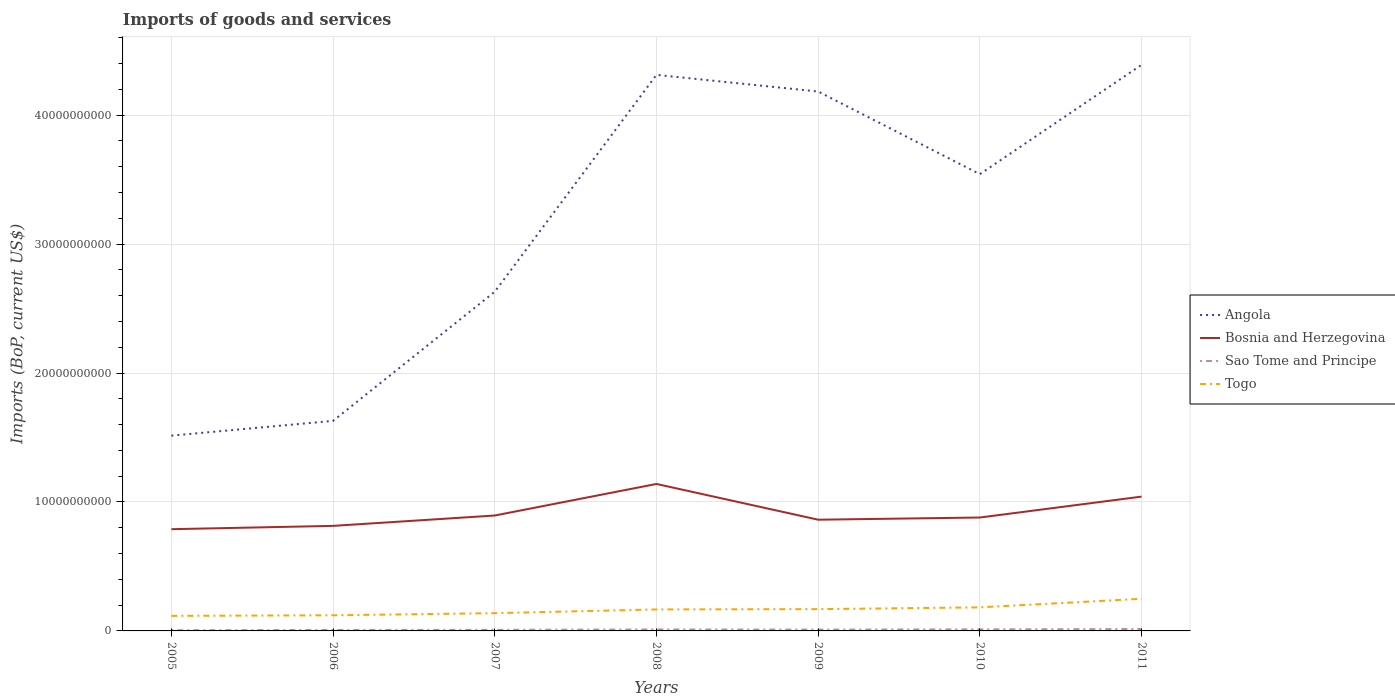How many different coloured lines are there?
Make the answer very short. 4. Across all years, what is the maximum amount spent on imports in Angola?
Offer a terse response. 1.51e+1. What is the total amount spent on imports in Angola in the graph?
Your response must be concise. -1.76e+1. What is the difference between the highest and the second highest amount spent on imports in Sao Tome and Principe?
Your answer should be very brief. 9.44e+07. Is the amount spent on imports in Sao Tome and Principe strictly greater than the amount spent on imports in Bosnia and Herzegovina over the years?
Your response must be concise. Yes. How many lines are there?
Give a very brief answer. 4. Are the values on the major ticks of Y-axis written in scientific E-notation?
Ensure brevity in your answer.  No. Does the graph contain any zero values?
Make the answer very short. No. What is the title of the graph?
Give a very brief answer. Imports of goods and services. What is the label or title of the Y-axis?
Your answer should be very brief. Imports (BoP, current US$). What is the Imports (BoP, current US$) of Angola in 2005?
Your answer should be very brief. 1.51e+1. What is the Imports (BoP, current US$) in Bosnia and Herzegovina in 2005?
Your answer should be very brief. 7.89e+09. What is the Imports (BoP, current US$) in Sao Tome and Principe in 2005?
Provide a short and direct response. 5.27e+07. What is the Imports (BoP, current US$) in Togo in 2005?
Offer a terse response. 1.17e+09. What is the Imports (BoP, current US$) in Angola in 2006?
Your answer should be compact. 1.63e+1. What is the Imports (BoP, current US$) of Bosnia and Herzegovina in 2006?
Make the answer very short. 8.15e+09. What is the Imports (BoP, current US$) of Sao Tome and Principe in 2006?
Keep it short and to the point. 7.70e+07. What is the Imports (BoP, current US$) in Togo in 2006?
Your response must be concise. 1.21e+09. What is the Imports (BoP, current US$) of Angola in 2007?
Ensure brevity in your answer.  2.63e+1. What is the Imports (BoP, current US$) in Bosnia and Herzegovina in 2007?
Make the answer very short. 8.95e+09. What is the Imports (BoP, current US$) of Sao Tome and Principe in 2007?
Your answer should be very brief. 8.35e+07. What is the Imports (BoP, current US$) in Togo in 2007?
Your answer should be very brief. 1.38e+09. What is the Imports (BoP, current US$) of Angola in 2008?
Provide a succinct answer. 4.31e+1. What is the Imports (BoP, current US$) of Bosnia and Herzegovina in 2008?
Make the answer very short. 1.14e+1. What is the Imports (BoP, current US$) of Sao Tome and Principe in 2008?
Your answer should be very brief. 1.14e+08. What is the Imports (BoP, current US$) in Togo in 2008?
Ensure brevity in your answer.  1.67e+09. What is the Imports (BoP, current US$) in Angola in 2009?
Offer a very short reply. 4.18e+1. What is the Imports (BoP, current US$) in Bosnia and Herzegovina in 2009?
Offer a very short reply. 8.62e+09. What is the Imports (BoP, current US$) in Sao Tome and Principe in 2009?
Your answer should be compact. 1.03e+08. What is the Imports (BoP, current US$) in Togo in 2009?
Keep it short and to the point. 1.69e+09. What is the Imports (BoP, current US$) in Angola in 2010?
Provide a short and direct response. 3.54e+1. What is the Imports (BoP, current US$) of Bosnia and Herzegovina in 2010?
Your response must be concise. 8.79e+09. What is the Imports (BoP, current US$) of Sao Tome and Principe in 2010?
Provide a short and direct response. 1.21e+08. What is the Imports (BoP, current US$) in Togo in 2010?
Offer a very short reply. 1.83e+09. What is the Imports (BoP, current US$) of Angola in 2011?
Make the answer very short. 4.39e+1. What is the Imports (BoP, current US$) of Bosnia and Herzegovina in 2011?
Provide a short and direct response. 1.04e+1. What is the Imports (BoP, current US$) in Sao Tome and Principe in 2011?
Provide a succinct answer. 1.47e+08. What is the Imports (BoP, current US$) in Togo in 2011?
Your answer should be compact. 2.49e+09. Across all years, what is the maximum Imports (BoP, current US$) of Angola?
Ensure brevity in your answer.  4.39e+1. Across all years, what is the maximum Imports (BoP, current US$) of Bosnia and Herzegovina?
Ensure brevity in your answer.  1.14e+1. Across all years, what is the maximum Imports (BoP, current US$) of Sao Tome and Principe?
Offer a very short reply. 1.47e+08. Across all years, what is the maximum Imports (BoP, current US$) in Togo?
Your answer should be very brief. 2.49e+09. Across all years, what is the minimum Imports (BoP, current US$) of Angola?
Offer a terse response. 1.51e+1. Across all years, what is the minimum Imports (BoP, current US$) of Bosnia and Herzegovina?
Your response must be concise. 7.89e+09. Across all years, what is the minimum Imports (BoP, current US$) of Sao Tome and Principe?
Your response must be concise. 5.27e+07. Across all years, what is the minimum Imports (BoP, current US$) in Togo?
Offer a terse response. 1.17e+09. What is the total Imports (BoP, current US$) of Angola in the graph?
Provide a short and direct response. 2.22e+11. What is the total Imports (BoP, current US$) of Bosnia and Herzegovina in the graph?
Provide a succinct answer. 6.42e+1. What is the total Imports (BoP, current US$) of Sao Tome and Principe in the graph?
Keep it short and to the point. 6.97e+08. What is the total Imports (BoP, current US$) in Togo in the graph?
Provide a succinct answer. 1.14e+1. What is the difference between the Imports (BoP, current US$) of Angola in 2005 and that in 2006?
Make the answer very short. -1.14e+09. What is the difference between the Imports (BoP, current US$) of Bosnia and Herzegovina in 2005 and that in 2006?
Keep it short and to the point. -2.56e+08. What is the difference between the Imports (BoP, current US$) of Sao Tome and Principe in 2005 and that in 2006?
Your answer should be very brief. -2.43e+07. What is the difference between the Imports (BoP, current US$) of Togo in 2005 and that in 2006?
Your answer should be compact. -4.51e+07. What is the difference between the Imports (BoP, current US$) of Angola in 2005 and that in 2007?
Your response must be concise. -1.12e+1. What is the difference between the Imports (BoP, current US$) of Bosnia and Herzegovina in 2005 and that in 2007?
Your response must be concise. -1.06e+09. What is the difference between the Imports (BoP, current US$) of Sao Tome and Principe in 2005 and that in 2007?
Your answer should be compact. -3.09e+07. What is the difference between the Imports (BoP, current US$) in Togo in 2005 and that in 2007?
Give a very brief answer. -2.09e+08. What is the difference between the Imports (BoP, current US$) in Angola in 2005 and that in 2008?
Offer a very short reply. -2.80e+1. What is the difference between the Imports (BoP, current US$) in Bosnia and Herzegovina in 2005 and that in 2008?
Your answer should be compact. -3.51e+09. What is the difference between the Imports (BoP, current US$) in Sao Tome and Principe in 2005 and that in 2008?
Provide a short and direct response. -6.09e+07. What is the difference between the Imports (BoP, current US$) in Togo in 2005 and that in 2008?
Keep it short and to the point. -4.98e+08. What is the difference between the Imports (BoP, current US$) of Angola in 2005 and that in 2009?
Your response must be concise. -2.67e+1. What is the difference between the Imports (BoP, current US$) of Bosnia and Herzegovina in 2005 and that in 2009?
Make the answer very short. -7.35e+08. What is the difference between the Imports (BoP, current US$) of Sao Tome and Principe in 2005 and that in 2009?
Give a very brief answer. -5.01e+07. What is the difference between the Imports (BoP, current US$) in Togo in 2005 and that in 2009?
Make the answer very short. -5.22e+08. What is the difference between the Imports (BoP, current US$) of Angola in 2005 and that in 2010?
Ensure brevity in your answer.  -2.03e+1. What is the difference between the Imports (BoP, current US$) of Bosnia and Herzegovina in 2005 and that in 2010?
Keep it short and to the point. -9.04e+08. What is the difference between the Imports (BoP, current US$) of Sao Tome and Principe in 2005 and that in 2010?
Make the answer very short. -6.79e+07. What is the difference between the Imports (BoP, current US$) in Togo in 2005 and that in 2010?
Your answer should be compact. -6.60e+08. What is the difference between the Imports (BoP, current US$) of Angola in 2005 and that in 2011?
Ensure brevity in your answer.  -2.88e+1. What is the difference between the Imports (BoP, current US$) in Bosnia and Herzegovina in 2005 and that in 2011?
Ensure brevity in your answer.  -2.53e+09. What is the difference between the Imports (BoP, current US$) of Sao Tome and Principe in 2005 and that in 2011?
Your answer should be very brief. -9.44e+07. What is the difference between the Imports (BoP, current US$) of Togo in 2005 and that in 2011?
Your answer should be very brief. -1.33e+09. What is the difference between the Imports (BoP, current US$) of Angola in 2006 and that in 2007?
Your response must be concise. -1.00e+1. What is the difference between the Imports (BoP, current US$) of Bosnia and Herzegovina in 2006 and that in 2007?
Give a very brief answer. -8.03e+08. What is the difference between the Imports (BoP, current US$) in Sao Tome and Principe in 2006 and that in 2007?
Give a very brief answer. -6.53e+06. What is the difference between the Imports (BoP, current US$) in Togo in 2006 and that in 2007?
Your answer should be compact. -1.64e+08. What is the difference between the Imports (BoP, current US$) in Angola in 2006 and that in 2008?
Your answer should be very brief. -2.68e+1. What is the difference between the Imports (BoP, current US$) in Bosnia and Herzegovina in 2006 and that in 2008?
Your response must be concise. -3.25e+09. What is the difference between the Imports (BoP, current US$) of Sao Tome and Principe in 2006 and that in 2008?
Make the answer very short. -3.66e+07. What is the difference between the Imports (BoP, current US$) in Togo in 2006 and that in 2008?
Make the answer very short. -4.53e+08. What is the difference between the Imports (BoP, current US$) in Angola in 2006 and that in 2009?
Provide a short and direct response. -2.55e+1. What is the difference between the Imports (BoP, current US$) in Bosnia and Herzegovina in 2006 and that in 2009?
Provide a succinct answer. -4.79e+08. What is the difference between the Imports (BoP, current US$) in Sao Tome and Principe in 2006 and that in 2009?
Offer a terse response. -2.57e+07. What is the difference between the Imports (BoP, current US$) in Togo in 2006 and that in 2009?
Keep it short and to the point. -4.77e+08. What is the difference between the Imports (BoP, current US$) of Angola in 2006 and that in 2010?
Offer a very short reply. -1.91e+1. What is the difference between the Imports (BoP, current US$) in Bosnia and Herzegovina in 2006 and that in 2010?
Ensure brevity in your answer.  -6.48e+08. What is the difference between the Imports (BoP, current US$) of Sao Tome and Principe in 2006 and that in 2010?
Your response must be concise. -4.35e+07. What is the difference between the Imports (BoP, current US$) in Togo in 2006 and that in 2010?
Your response must be concise. -6.15e+08. What is the difference between the Imports (BoP, current US$) in Angola in 2006 and that in 2011?
Offer a very short reply. -2.76e+1. What is the difference between the Imports (BoP, current US$) of Bosnia and Herzegovina in 2006 and that in 2011?
Make the answer very short. -2.27e+09. What is the difference between the Imports (BoP, current US$) in Sao Tome and Principe in 2006 and that in 2011?
Ensure brevity in your answer.  -7.01e+07. What is the difference between the Imports (BoP, current US$) in Togo in 2006 and that in 2011?
Give a very brief answer. -1.28e+09. What is the difference between the Imports (BoP, current US$) of Angola in 2007 and that in 2008?
Your answer should be very brief. -1.68e+1. What is the difference between the Imports (BoP, current US$) in Bosnia and Herzegovina in 2007 and that in 2008?
Provide a short and direct response. -2.45e+09. What is the difference between the Imports (BoP, current US$) of Sao Tome and Principe in 2007 and that in 2008?
Ensure brevity in your answer.  -3.01e+07. What is the difference between the Imports (BoP, current US$) of Togo in 2007 and that in 2008?
Keep it short and to the point. -2.89e+08. What is the difference between the Imports (BoP, current US$) of Angola in 2007 and that in 2009?
Ensure brevity in your answer.  -1.55e+1. What is the difference between the Imports (BoP, current US$) in Bosnia and Herzegovina in 2007 and that in 2009?
Keep it short and to the point. 3.25e+08. What is the difference between the Imports (BoP, current US$) of Sao Tome and Principe in 2007 and that in 2009?
Offer a very short reply. -1.92e+07. What is the difference between the Imports (BoP, current US$) of Togo in 2007 and that in 2009?
Offer a very short reply. -3.12e+08. What is the difference between the Imports (BoP, current US$) in Angola in 2007 and that in 2010?
Your answer should be very brief. -9.12e+09. What is the difference between the Imports (BoP, current US$) in Bosnia and Herzegovina in 2007 and that in 2010?
Provide a succinct answer. 1.56e+08. What is the difference between the Imports (BoP, current US$) in Sao Tome and Principe in 2007 and that in 2010?
Your answer should be compact. -3.70e+07. What is the difference between the Imports (BoP, current US$) in Togo in 2007 and that in 2010?
Make the answer very short. -4.51e+08. What is the difference between the Imports (BoP, current US$) of Angola in 2007 and that in 2011?
Keep it short and to the point. -1.76e+1. What is the difference between the Imports (BoP, current US$) in Bosnia and Herzegovina in 2007 and that in 2011?
Give a very brief answer. -1.47e+09. What is the difference between the Imports (BoP, current US$) in Sao Tome and Principe in 2007 and that in 2011?
Give a very brief answer. -6.35e+07. What is the difference between the Imports (BoP, current US$) of Togo in 2007 and that in 2011?
Your response must be concise. -1.12e+09. What is the difference between the Imports (BoP, current US$) of Angola in 2008 and that in 2009?
Offer a very short reply. 1.29e+09. What is the difference between the Imports (BoP, current US$) of Bosnia and Herzegovina in 2008 and that in 2009?
Provide a succinct answer. 2.77e+09. What is the difference between the Imports (BoP, current US$) in Sao Tome and Principe in 2008 and that in 2009?
Ensure brevity in your answer.  1.08e+07. What is the difference between the Imports (BoP, current US$) in Togo in 2008 and that in 2009?
Give a very brief answer. -2.35e+07. What is the difference between the Imports (BoP, current US$) in Angola in 2008 and that in 2010?
Your response must be concise. 7.70e+09. What is the difference between the Imports (BoP, current US$) in Bosnia and Herzegovina in 2008 and that in 2010?
Your answer should be very brief. 2.60e+09. What is the difference between the Imports (BoP, current US$) of Sao Tome and Principe in 2008 and that in 2010?
Give a very brief answer. -6.93e+06. What is the difference between the Imports (BoP, current US$) of Togo in 2008 and that in 2010?
Your answer should be very brief. -1.62e+08. What is the difference between the Imports (BoP, current US$) of Angola in 2008 and that in 2011?
Your response must be concise. -7.77e+08. What is the difference between the Imports (BoP, current US$) in Bosnia and Herzegovina in 2008 and that in 2011?
Provide a short and direct response. 9.82e+08. What is the difference between the Imports (BoP, current US$) in Sao Tome and Principe in 2008 and that in 2011?
Your answer should be very brief. -3.35e+07. What is the difference between the Imports (BoP, current US$) of Togo in 2008 and that in 2011?
Provide a short and direct response. -8.27e+08. What is the difference between the Imports (BoP, current US$) in Angola in 2009 and that in 2010?
Provide a succinct answer. 6.41e+09. What is the difference between the Imports (BoP, current US$) in Bosnia and Herzegovina in 2009 and that in 2010?
Give a very brief answer. -1.69e+08. What is the difference between the Imports (BoP, current US$) in Sao Tome and Principe in 2009 and that in 2010?
Ensure brevity in your answer.  -1.78e+07. What is the difference between the Imports (BoP, current US$) in Togo in 2009 and that in 2010?
Your answer should be compact. -1.38e+08. What is the difference between the Imports (BoP, current US$) in Angola in 2009 and that in 2011?
Your answer should be very brief. -2.07e+09. What is the difference between the Imports (BoP, current US$) of Bosnia and Herzegovina in 2009 and that in 2011?
Ensure brevity in your answer.  -1.79e+09. What is the difference between the Imports (BoP, current US$) in Sao Tome and Principe in 2009 and that in 2011?
Provide a short and direct response. -4.43e+07. What is the difference between the Imports (BoP, current US$) in Togo in 2009 and that in 2011?
Your response must be concise. -8.03e+08. What is the difference between the Imports (BoP, current US$) in Angola in 2010 and that in 2011?
Provide a short and direct response. -8.48e+09. What is the difference between the Imports (BoP, current US$) of Bosnia and Herzegovina in 2010 and that in 2011?
Keep it short and to the point. -1.62e+09. What is the difference between the Imports (BoP, current US$) in Sao Tome and Principe in 2010 and that in 2011?
Offer a very short reply. -2.66e+07. What is the difference between the Imports (BoP, current US$) of Togo in 2010 and that in 2011?
Your answer should be very brief. -6.65e+08. What is the difference between the Imports (BoP, current US$) in Angola in 2005 and the Imports (BoP, current US$) in Bosnia and Herzegovina in 2006?
Offer a terse response. 7.00e+09. What is the difference between the Imports (BoP, current US$) in Angola in 2005 and the Imports (BoP, current US$) in Sao Tome and Principe in 2006?
Your response must be concise. 1.51e+1. What is the difference between the Imports (BoP, current US$) in Angola in 2005 and the Imports (BoP, current US$) in Togo in 2006?
Offer a very short reply. 1.39e+1. What is the difference between the Imports (BoP, current US$) of Bosnia and Herzegovina in 2005 and the Imports (BoP, current US$) of Sao Tome and Principe in 2006?
Your response must be concise. 7.81e+09. What is the difference between the Imports (BoP, current US$) of Bosnia and Herzegovina in 2005 and the Imports (BoP, current US$) of Togo in 2006?
Your answer should be compact. 6.68e+09. What is the difference between the Imports (BoP, current US$) of Sao Tome and Principe in 2005 and the Imports (BoP, current US$) of Togo in 2006?
Provide a short and direct response. -1.16e+09. What is the difference between the Imports (BoP, current US$) in Angola in 2005 and the Imports (BoP, current US$) in Bosnia and Herzegovina in 2007?
Give a very brief answer. 6.19e+09. What is the difference between the Imports (BoP, current US$) in Angola in 2005 and the Imports (BoP, current US$) in Sao Tome and Principe in 2007?
Your response must be concise. 1.51e+1. What is the difference between the Imports (BoP, current US$) in Angola in 2005 and the Imports (BoP, current US$) in Togo in 2007?
Offer a terse response. 1.38e+1. What is the difference between the Imports (BoP, current US$) of Bosnia and Herzegovina in 2005 and the Imports (BoP, current US$) of Sao Tome and Principe in 2007?
Provide a succinct answer. 7.81e+09. What is the difference between the Imports (BoP, current US$) of Bosnia and Herzegovina in 2005 and the Imports (BoP, current US$) of Togo in 2007?
Give a very brief answer. 6.51e+09. What is the difference between the Imports (BoP, current US$) of Sao Tome and Principe in 2005 and the Imports (BoP, current US$) of Togo in 2007?
Give a very brief answer. -1.32e+09. What is the difference between the Imports (BoP, current US$) in Angola in 2005 and the Imports (BoP, current US$) in Bosnia and Herzegovina in 2008?
Ensure brevity in your answer.  3.75e+09. What is the difference between the Imports (BoP, current US$) in Angola in 2005 and the Imports (BoP, current US$) in Sao Tome and Principe in 2008?
Make the answer very short. 1.50e+1. What is the difference between the Imports (BoP, current US$) of Angola in 2005 and the Imports (BoP, current US$) of Togo in 2008?
Offer a terse response. 1.35e+1. What is the difference between the Imports (BoP, current US$) of Bosnia and Herzegovina in 2005 and the Imports (BoP, current US$) of Sao Tome and Principe in 2008?
Your answer should be very brief. 7.78e+09. What is the difference between the Imports (BoP, current US$) of Bosnia and Herzegovina in 2005 and the Imports (BoP, current US$) of Togo in 2008?
Make the answer very short. 6.22e+09. What is the difference between the Imports (BoP, current US$) of Sao Tome and Principe in 2005 and the Imports (BoP, current US$) of Togo in 2008?
Provide a short and direct response. -1.61e+09. What is the difference between the Imports (BoP, current US$) of Angola in 2005 and the Imports (BoP, current US$) of Bosnia and Herzegovina in 2009?
Give a very brief answer. 6.52e+09. What is the difference between the Imports (BoP, current US$) of Angola in 2005 and the Imports (BoP, current US$) of Sao Tome and Principe in 2009?
Provide a succinct answer. 1.50e+1. What is the difference between the Imports (BoP, current US$) in Angola in 2005 and the Imports (BoP, current US$) in Togo in 2009?
Give a very brief answer. 1.35e+1. What is the difference between the Imports (BoP, current US$) in Bosnia and Herzegovina in 2005 and the Imports (BoP, current US$) in Sao Tome and Principe in 2009?
Your answer should be very brief. 7.79e+09. What is the difference between the Imports (BoP, current US$) in Bosnia and Herzegovina in 2005 and the Imports (BoP, current US$) in Togo in 2009?
Ensure brevity in your answer.  6.20e+09. What is the difference between the Imports (BoP, current US$) of Sao Tome and Principe in 2005 and the Imports (BoP, current US$) of Togo in 2009?
Give a very brief answer. -1.64e+09. What is the difference between the Imports (BoP, current US$) of Angola in 2005 and the Imports (BoP, current US$) of Bosnia and Herzegovina in 2010?
Keep it short and to the point. 6.35e+09. What is the difference between the Imports (BoP, current US$) in Angola in 2005 and the Imports (BoP, current US$) in Sao Tome and Principe in 2010?
Offer a very short reply. 1.50e+1. What is the difference between the Imports (BoP, current US$) of Angola in 2005 and the Imports (BoP, current US$) of Togo in 2010?
Your answer should be compact. 1.33e+1. What is the difference between the Imports (BoP, current US$) of Bosnia and Herzegovina in 2005 and the Imports (BoP, current US$) of Sao Tome and Principe in 2010?
Your answer should be very brief. 7.77e+09. What is the difference between the Imports (BoP, current US$) of Bosnia and Herzegovina in 2005 and the Imports (BoP, current US$) of Togo in 2010?
Your response must be concise. 6.06e+09. What is the difference between the Imports (BoP, current US$) in Sao Tome and Principe in 2005 and the Imports (BoP, current US$) in Togo in 2010?
Provide a short and direct response. -1.78e+09. What is the difference between the Imports (BoP, current US$) in Angola in 2005 and the Imports (BoP, current US$) in Bosnia and Herzegovina in 2011?
Your response must be concise. 4.73e+09. What is the difference between the Imports (BoP, current US$) of Angola in 2005 and the Imports (BoP, current US$) of Sao Tome and Principe in 2011?
Offer a very short reply. 1.50e+1. What is the difference between the Imports (BoP, current US$) of Angola in 2005 and the Imports (BoP, current US$) of Togo in 2011?
Make the answer very short. 1.27e+1. What is the difference between the Imports (BoP, current US$) in Bosnia and Herzegovina in 2005 and the Imports (BoP, current US$) in Sao Tome and Principe in 2011?
Offer a terse response. 7.74e+09. What is the difference between the Imports (BoP, current US$) in Bosnia and Herzegovina in 2005 and the Imports (BoP, current US$) in Togo in 2011?
Make the answer very short. 5.40e+09. What is the difference between the Imports (BoP, current US$) in Sao Tome and Principe in 2005 and the Imports (BoP, current US$) in Togo in 2011?
Provide a succinct answer. -2.44e+09. What is the difference between the Imports (BoP, current US$) of Angola in 2006 and the Imports (BoP, current US$) of Bosnia and Herzegovina in 2007?
Give a very brief answer. 7.34e+09. What is the difference between the Imports (BoP, current US$) in Angola in 2006 and the Imports (BoP, current US$) in Sao Tome and Principe in 2007?
Your response must be concise. 1.62e+1. What is the difference between the Imports (BoP, current US$) of Angola in 2006 and the Imports (BoP, current US$) of Togo in 2007?
Make the answer very short. 1.49e+1. What is the difference between the Imports (BoP, current US$) of Bosnia and Herzegovina in 2006 and the Imports (BoP, current US$) of Sao Tome and Principe in 2007?
Your answer should be compact. 8.06e+09. What is the difference between the Imports (BoP, current US$) of Bosnia and Herzegovina in 2006 and the Imports (BoP, current US$) of Togo in 2007?
Your response must be concise. 6.77e+09. What is the difference between the Imports (BoP, current US$) in Sao Tome and Principe in 2006 and the Imports (BoP, current US$) in Togo in 2007?
Your answer should be very brief. -1.30e+09. What is the difference between the Imports (BoP, current US$) of Angola in 2006 and the Imports (BoP, current US$) of Bosnia and Herzegovina in 2008?
Your answer should be very brief. 4.89e+09. What is the difference between the Imports (BoP, current US$) in Angola in 2006 and the Imports (BoP, current US$) in Sao Tome and Principe in 2008?
Provide a succinct answer. 1.62e+1. What is the difference between the Imports (BoP, current US$) in Angola in 2006 and the Imports (BoP, current US$) in Togo in 2008?
Offer a very short reply. 1.46e+1. What is the difference between the Imports (BoP, current US$) in Bosnia and Herzegovina in 2006 and the Imports (BoP, current US$) in Sao Tome and Principe in 2008?
Offer a terse response. 8.03e+09. What is the difference between the Imports (BoP, current US$) in Bosnia and Herzegovina in 2006 and the Imports (BoP, current US$) in Togo in 2008?
Offer a very short reply. 6.48e+09. What is the difference between the Imports (BoP, current US$) in Sao Tome and Principe in 2006 and the Imports (BoP, current US$) in Togo in 2008?
Ensure brevity in your answer.  -1.59e+09. What is the difference between the Imports (BoP, current US$) of Angola in 2006 and the Imports (BoP, current US$) of Bosnia and Herzegovina in 2009?
Your response must be concise. 7.66e+09. What is the difference between the Imports (BoP, current US$) of Angola in 2006 and the Imports (BoP, current US$) of Sao Tome and Principe in 2009?
Provide a succinct answer. 1.62e+1. What is the difference between the Imports (BoP, current US$) of Angola in 2006 and the Imports (BoP, current US$) of Togo in 2009?
Provide a short and direct response. 1.46e+1. What is the difference between the Imports (BoP, current US$) of Bosnia and Herzegovina in 2006 and the Imports (BoP, current US$) of Sao Tome and Principe in 2009?
Keep it short and to the point. 8.04e+09. What is the difference between the Imports (BoP, current US$) in Bosnia and Herzegovina in 2006 and the Imports (BoP, current US$) in Togo in 2009?
Offer a very short reply. 6.46e+09. What is the difference between the Imports (BoP, current US$) in Sao Tome and Principe in 2006 and the Imports (BoP, current US$) in Togo in 2009?
Provide a succinct answer. -1.61e+09. What is the difference between the Imports (BoP, current US$) in Angola in 2006 and the Imports (BoP, current US$) in Bosnia and Herzegovina in 2010?
Offer a terse response. 7.49e+09. What is the difference between the Imports (BoP, current US$) in Angola in 2006 and the Imports (BoP, current US$) in Sao Tome and Principe in 2010?
Your answer should be very brief. 1.62e+1. What is the difference between the Imports (BoP, current US$) of Angola in 2006 and the Imports (BoP, current US$) of Togo in 2010?
Keep it short and to the point. 1.45e+1. What is the difference between the Imports (BoP, current US$) of Bosnia and Herzegovina in 2006 and the Imports (BoP, current US$) of Sao Tome and Principe in 2010?
Provide a succinct answer. 8.03e+09. What is the difference between the Imports (BoP, current US$) in Bosnia and Herzegovina in 2006 and the Imports (BoP, current US$) in Togo in 2010?
Offer a very short reply. 6.32e+09. What is the difference between the Imports (BoP, current US$) of Sao Tome and Principe in 2006 and the Imports (BoP, current US$) of Togo in 2010?
Ensure brevity in your answer.  -1.75e+09. What is the difference between the Imports (BoP, current US$) of Angola in 2006 and the Imports (BoP, current US$) of Bosnia and Herzegovina in 2011?
Offer a terse response. 5.87e+09. What is the difference between the Imports (BoP, current US$) in Angola in 2006 and the Imports (BoP, current US$) in Sao Tome and Principe in 2011?
Your answer should be compact. 1.61e+1. What is the difference between the Imports (BoP, current US$) of Angola in 2006 and the Imports (BoP, current US$) of Togo in 2011?
Your answer should be very brief. 1.38e+1. What is the difference between the Imports (BoP, current US$) of Bosnia and Herzegovina in 2006 and the Imports (BoP, current US$) of Sao Tome and Principe in 2011?
Offer a terse response. 8.00e+09. What is the difference between the Imports (BoP, current US$) of Bosnia and Herzegovina in 2006 and the Imports (BoP, current US$) of Togo in 2011?
Keep it short and to the point. 5.65e+09. What is the difference between the Imports (BoP, current US$) in Sao Tome and Principe in 2006 and the Imports (BoP, current US$) in Togo in 2011?
Your answer should be very brief. -2.42e+09. What is the difference between the Imports (BoP, current US$) of Angola in 2007 and the Imports (BoP, current US$) of Bosnia and Herzegovina in 2008?
Ensure brevity in your answer.  1.49e+1. What is the difference between the Imports (BoP, current US$) in Angola in 2007 and the Imports (BoP, current US$) in Sao Tome and Principe in 2008?
Your answer should be very brief. 2.62e+1. What is the difference between the Imports (BoP, current US$) in Angola in 2007 and the Imports (BoP, current US$) in Togo in 2008?
Offer a terse response. 2.46e+1. What is the difference between the Imports (BoP, current US$) of Bosnia and Herzegovina in 2007 and the Imports (BoP, current US$) of Sao Tome and Principe in 2008?
Ensure brevity in your answer.  8.84e+09. What is the difference between the Imports (BoP, current US$) in Bosnia and Herzegovina in 2007 and the Imports (BoP, current US$) in Togo in 2008?
Provide a succinct answer. 7.28e+09. What is the difference between the Imports (BoP, current US$) of Sao Tome and Principe in 2007 and the Imports (BoP, current US$) of Togo in 2008?
Offer a terse response. -1.58e+09. What is the difference between the Imports (BoP, current US$) of Angola in 2007 and the Imports (BoP, current US$) of Bosnia and Herzegovina in 2009?
Make the answer very short. 1.77e+1. What is the difference between the Imports (BoP, current US$) in Angola in 2007 and the Imports (BoP, current US$) in Sao Tome and Principe in 2009?
Offer a very short reply. 2.62e+1. What is the difference between the Imports (BoP, current US$) in Angola in 2007 and the Imports (BoP, current US$) in Togo in 2009?
Give a very brief answer. 2.46e+1. What is the difference between the Imports (BoP, current US$) in Bosnia and Herzegovina in 2007 and the Imports (BoP, current US$) in Sao Tome and Principe in 2009?
Offer a very short reply. 8.85e+09. What is the difference between the Imports (BoP, current US$) of Bosnia and Herzegovina in 2007 and the Imports (BoP, current US$) of Togo in 2009?
Give a very brief answer. 7.26e+09. What is the difference between the Imports (BoP, current US$) in Sao Tome and Principe in 2007 and the Imports (BoP, current US$) in Togo in 2009?
Offer a very short reply. -1.61e+09. What is the difference between the Imports (BoP, current US$) of Angola in 2007 and the Imports (BoP, current US$) of Bosnia and Herzegovina in 2010?
Provide a succinct answer. 1.75e+1. What is the difference between the Imports (BoP, current US$) in Angola in 2007 and the Imports (BoP, current US$) in Sao Tome and Principe in 2010?
Offer a terse response. 2.62e+1. What is the difference between the Imports (BoP, current US$) of Angola in 2007 and the Imports (BoP, current US$) of Togo in 2010?
Offer a very short reply. 2.45e+1. What is the difference between the Imports (BoP, current US$) in Bosnia and Herzegovina in 2007 and the Imports (BoP, current US$) in Sao Tome and Principe in 2010?
Give a very brief answer. 8.83e+09. What is the difference between the Imports (BoP, current US$) of Bosnia and Herzegovina in 2007 and the Imports (BoP, current US$) of Togo in 2010?
Your answer should be compact. 7.12e+09. What is the difference between the Imports (BoP, current US$) of Sao Tome and Principe in 2007 and the Imports (BoP, current US$) of Togo in 2010?
Make the answer very short. -1.74e+09. What is the difference between the Imports (BoP, current US$) in Angola in 2007 and the Imports (BoP, current US$) in Bosnia and Herzegovina in 2011?
Provide a succinct answer. 1.59e+1. What is the difference between the Imports (BoP, current US$) of Angola in 2007 and the Imports (BoP, current US$) of Sao Tome and Principe in 2011?
Offer a terse response. 2.62e+1. What is the difference between the Imports (BoP, current US$) in Angola in 2007 and the Imports (BoP, current US$) in Togo in 2011?
Your answer should be very brief. 2.38e+1. What is the difference between the Imports (BoP, current US$) of Bosnia and Herzegovina in 2007 and the Imports (BoP, current US$) of Sao Tome and Principe in 2011?
Give a very brief answer. 8.80e+09. What is the difference between the Imports (BoP, current US$) in Bosnia and Herzegovina in 2007 and the Imports (BoP, current US$) in Togo in 2011?
Ensure brevity in your answer.  6.46e+09. What is the difference between the Imports (BoP, current US$) in Sao Tome and Principe in 2007 and the Imports (BoP, current US$) in Togo in 2011?
Your response must be concise. -2.41e+09. What is the difference between the Imports (BoP, current US$) of Angola in 2008 and the Imports (BoP, current US$) of Bosnia and Herzegovina in 2009?
Offer a very short reply. 3.45e+1. What is the difference between the Imports (BoP, current US$) in Angola in 2008 and the Imports (BoP, current US$) in Sao Tome and Principe in 2009?
Provide a succinct answer. 4.30e+1. What is the difference between the Imports (BoP, current US$) of Angola in 2008 and the Imports (BoP, current US$) of Togo in 2009?
Your answer should be very brief. 4.14e+1. What is the difference between the Imports (BoP, current US$) of Bosnia and Herzegovina in 2008 and the Imports (BoP, current US$) of Sao Tome and Principe in 2009?
Make the answer very short. 1.13e+1. What is the difference between the Imports (BoP, current US$) in Bosnia and Herzegovina in 2008 and the Imports (BoP, current US$) in Togo in 2009?
Make the answer very short. 9.71e+09. What is the difference between the Imports (BoP, current US$) of Sao Tome and Principe in 2008 and the Imports (BoP, current US$) of Togo in 2009?
Provide a short and direct response. -1.58e+09. What is the difference between the Imports (BoP, current US$) of Angola in 2008 and the Imports (BoP, current US$) of Bosnia and Herzegovina in 2010?
Offer a terse response. 3.43e+1. What is the difference between the Imports (BoP, current US$) in Angola in 2008 and the Imports (BoP, current US$) in Sao Tome and Principe in 2010?
Provide a short and direct response. 4.30e+1. What is the difference between the Imports (BoP, current US$) in Angola in 2008 and the Imports (BoP, current US$) in Togo in 2010?
Make the answer very short. 4.13e+1. What is the difference between the Imports (BoP, current US$) of Bosnia and Herzegovina in 2008 and the Imports (BoP, current US$) of Sao Tome and Principe in 2010?
Your answer should be compact. 1.13e+1. What is the difference between the Imports (BoP, current US$) in Bosnia and Herzegovina in 2008 and the Imports (BoP, current US$) in Togo in 2010?
Provide a succinct answer. 9.57e+09. What is the difference between the Imports (BoP, current US$) in Sao Tome and Principe in 2008 and the Imports (BoP, current US$) in Togo in 2010?
Your answer should be compact. -1.71e+09. What is the difference between the Imports (BoP, current US$) in Angola in 2008 and the Imports (BoP, current US$) in Bosnia and Herzegovina in 2011?
Your answer should be compact. 3.27e+1. What is the difference between the Imports (BoP, current US$) of Angola in 2008 and the Imports (BoP, current US$) of Sao Tome and Principe in 2011?
Your answer should be compact. 4.30e+1. What is the difference between the Imports (BoP, current US$) of Angola in 2008 and the Imports (BoP, current US$) of Togo in 2011?
Give a very brief answer. 4.06e+1. What is the difference between the Imports (BoP, current US$) of Bosnia and Herzegovina in 2008 and the Imports (BoP, current US$) of Sao Tome and Principe in 2011?
Keep it short and to the point. 1.13e+1. What is the difference between the Imports (BoP, current US$) of Bosnia and Herzegovina in 2008 and the Imports (BoP, current US$) of Togo in 2011?
Give a very brief answer. 8.90e+09. What is the difference between the Imports (BoP, current US$) in Sao Tome and Principe in 2008 and the Imports (BoP, current US$) in Togo in 2011?
Keep it short and to the point. -2.38e+09. What is the difference between the Imports (BoP, current US$) of Angola in 2009 and the Imports (BoP, current US$) of Bosnia and Herzegovina in 2010?
Keep it short and to the point. 3.30e+1. What is the difference between the Imports (BoP, current US$) in Angola in 2009 and the Imports (BoP, current US$) in Sao Tome and Principe in 2010?
Keep it short and to the point. 4.17e+1. What is the difference between the Imports (BoP, current US$) in Angola in 2009 and the Imports (BoP, current US$) in Togo in 2010?
Your answer should be very brief. 4.00e+1. What is the difference between the Imports (BoP, current US$) in Bosnia and Herzegovina in 2009 and the Imports (BoP, current US$) in Sao Tome and Principe in 2010?
Offer a terse response. 8.50e+09. What is the difference between the Imports (BoP, current US$) of Bosnia and Herzegovina in 2009 and the Imports (BoP, current US$) of Togo in 2010?
Offer a very short reply. 6.80e+09. What is the difference between the Imports (BoP, current US$) in Sao Tome and Principe in 2009 and the Imports (BoP, current US$) in Togo in 2010?
Offer a very short reply. -1.73e+09. What is the difference between the Imports (BoP, current US$) in Angola in 2009 and the Imports (BoP, current US$) in Bosnia and Herzegovina in 2011?
Your response must be concise. 3.14e+1. What is the difference between the Imports (BoP, current US$) in Angola in 2009 and the Imports (BoP, current US$) in Sao Tome and Principe in 2011?
Your answer should be compact. 4.17e+1. What is the difference between the Imports (BoP, current US$) of Angola in 2009 and the Imports (BoP, current US$) of Togo in 2011?
Give a very brief answer. 3.93e+1. What is the difference between the Imports (BoP, current US$) of Bosnia and Herzegovina in 2009 and the Imports (BoP, current US$) of Sao Tome and Principe in 2011?
Give a very brief answer. 8.48e+09. What is the difference between the Imports (BoP, current US$) of Bosnia and Herzegovina in 2009 and the Imports (BoP, current US$) of Togo in 2011?
Make the answer very short. 6.13e+09. What is the difference between the Imports (BoP, current US$) of Sao Tome and Principe in 2009 and the Imports (BoP, current US$) of Togo in 2011?
Make the answer very short. -2.39e+09. What is the difference between the Imports (BoP, current US$) in Angola in 2010 and the Imports (BoP, current US$) in Bosnia and Herzegovina in 2011?
Your response must be concise. 2.50e+1. What is the difference between the Imports (BoP, current US$) of Angola in 2010 and the Imports (BoP, current US$) of Sao Tome and Principe in 2011?
Ensure brevity in your answer.  3.53e+1. What is the difference between the Imports (BoP, current US$) of Angola in 2010 and the Imports (BoP, current US$) of Togo in 2011?
Offer a terse response. 3.29e+1. What is the difference between the Imports (BoP, current US$) in Bosnia and Herzegovina in 2010 and the Imports (BoP, current US$) in Sao Tome and Principe in 2011?
Your answer should be very brief. 8.65e+09. What is the difference between the Imports (BoP, current US$) in Bosnia and Herzegovina in 2010 and the Imports (BoP, current US$) in Togo in 2011?
Make the answer very short. 6.30e+09. What is the difference between the Imports (BoP, current US$) of Sao Tome and Principe in 2010 and the Imports (BoP, current US$) of Togo in 2011?
Make the answer very short. -2.37e+09. What is the average Imports (BoP, current US$) of Angola per year?
Make the answer very short. 3.17e+1. What is the average Imports (BoP, current US$) of Bosnia and Herzegovina per year?
Keep it short and to the point. 9.17e+09. What is the average Imports (BoP, current US$) in Sao Tome and Principe per year?
Your answer should be compact. 9.96e+07. What is the average Imports (BoP, current US$) in Togo per year?
Your answer should be compact. 1.63e+09. In the year 2005, what is the difference between the Imports (BoP, current US$) of Angola and Imports (BoP, current US$) of Bosnia and Herzegovina?
Keep it short and to the point. 7.25e+09. In the year 2005, what is the difference between the Imports (BoP, current US$) of Angola and Imports (BoP, current US$) of Sao Tome and Principe?
Ensure brevity in your answer.  1.51e+1. In the year 2005, what is the difference between the Imports (BoP, current US$) of Angola and Imports (BoP, current US$) of Togo?
Ensure brevity in your answer.  1.40e+1. In the year 2005, what is the difference between the Imports (BoP, current US$) of Bosnia and Herzegovina and Imports (BoP, current US$) of Sao Tome and Principe?
Make the answer very short. 7.84e+09. In the year 2005, what is the difference between the Imports (BoP, current US$) of Bosnia and Herzegovina and Imports (BoP, current US$) of Togo?
Your answer should be very brief. 6.72e+09. In the year 2005, what is the difference between the Imports (BoP, current US$) of Sao Tome and Principe and Imports (BoP, current US$) of Togo?
Offer a terse response. -1.12e+09. In the year 2006, what is the difference between the Imports (BoP, current US$) of Angola and Imports (BoP, current US$) of Bosnia and Herzegovina?
Keep it short and to the point. 8.14e+09. In the year 2006, what is the difference between the Imports (BoP, current US$) in Angola and Imports (BoP, current US$) in Sao Tome and Principe?
Your answer should be compact. 1.62e+1. In the year 2006, what is the difference between the Imports (BoP, current US$) of Angola and Imports (BoP, current US$) of Togo?
Your response must be concise. 1.51e+1. In the year 2006, what is the difference between the Imports (BoP, current US$) in Bosnia and Herzegovina and Imports (BoP, current US$) in Sao Tome and Principe?
Your answer should be very brief. 8.07e+09. In the year 2006, what is the difference between the Imports (BoP, current US$) in Bosnia and Herzegovina and Imports (BoP, current US$) in Togo?
Give a very brief answer. 6.93e+09. In the year 2006, what is the difference between the Imports (BoP, current US$) of Sao Tome and Principe and Imports (BoP, current US$) of Togo?
Offer a terse response. -1.14e+09. In the year 2007, what is the difference between the Imports (BoP, current US$) in Angola and Imports (BoP, current US$) in Bosnia and Herzegovina?
Your answer should be compact. 1.74e+1. In the year 2007, what is the difference between the Imports (BoP, current US$) of Angola and Imports (BoP, current US$) of Sao Tome and Principe?
Your answer should be compact. 2.62e+1. In the year 2007, what is the difference between the Imports (BoP, current US$) of Angola and Imports (BoP, current US$) of Togo?
Your response must be concise. 2.49e+1. In the year 2007, what is the difference between the Imports (BoP, current US$) in Bosnia and Herzegovina and Imports (BoP, current US$) in Sao Tome and Principe?
Offer a very short reply. 8.87e+09. In the year 2007, what is the difference between the Imports (BoP, current US$) in Bosnia and Herzegovina and Imports (BoP, current US$) in Togo?
Make the answer very short. 7.57e+09. In the year 2007, what is the difference between the Imports (BoP, current US$) of Sao Tome and Principe and Imports (BoP, current US$) of Togo?
Your response must be concise. -1.29e+09. In the year 2008, what is the difference between the Imports (BoP, current US$) of Angola and Imports (BoP, current US$) of Bosnia and Herzegovina?
Give a very brief answer. 3.17e+1. In the year 2008, what is the difference between the Imports (BoP, current US$) in Angola and Imports (BoP, current US$) in Sao Tome and Principe?
Your response must be concise. 4.30e+1. In the year 2008, what is the difference between the Imports (BoP, current US$) in Angola and Imports (BoP, current US$) in Togo?
Provide a short and direct response. 4.15e+1. In the year 2008, what is the difference between the Imports (BoP, current US$) of Bosnia and Herzegovina and Imports (BoP, current US$) of Sao Tome and Principe?
Your answer should be very brief. 1.13e+1. In the year 2008, what is the difference between the Imports (BoP, current US$) in Bosnia and Herzegovina and Imports (BoP, current US$) in Togo?
Your answer should be compact. 9.73e+09. In the year 2008, what is the difference between the Imports (BoP, current US$) in Sao Tome and Principe and Imports (BoP, current US$) in Togo?
Offer a very short reply. -1.55e+09. In the year 2009, what is the difference between the Imports (BoP, current US$) in Angola and Imports (BoP, current US$) in Bosnia and Herzegovina?
Offer a very short reply. 3.32e+1. In the year 2009, what is the difference between the Imports (BoP, current US$) in Angola and Imports (BoP, current US$) in Sao Tome and Principe?
Offer a very short reply. 4.17e+1. In the year 2009, what is the difference between the Imports (BoP, current US$) of Angola and Imports (BoP, current US$) of Togo?
Provide a succinct answer. 4.01e+1. In the year 2009, what is the difference between the Imports (BoP, current US$) in Bosnia and Herzegovina and Imports (BoP, current US$) in Sao Tome and Principe?
Your response must be concise. 8.52e+09. In the year 2009, what is the difference between the Imports (BoP, current US$) of Bosnia and Herzegovina and Imports (BoP, current US$) of Togo?
Ensure brevity in your answer.  6.93e+09. In the year 2009, what is the difference between the Imports (BoP, current US$) in Sao Tome and Principe and Imports (BoP, current US$) in Togo?
Your response must be concise. -1.59e+09. In the year 2010, what is the difference between the Imports (BoP, current US$) of Angola and Imports (BoP, current US$) of Bosnia and Herzegovina?
Ensure brevity in your answer.  2.66e+1. In the year 2010, what is the difference between the Imports (BoP, current US$) of Angola and Imports (BoP, current US$) of Sao Tome and Principe?
Ensure brevity in your answer.  3.53e+1. In the year 2010, what is the difference between the Imports (BoP, current US$) in Angola and Imports (BoP, current US$) in Togo?
Your answer should be very brief. 3.36e+1. In the year 2010, what is the difference between the Imports (BoP, current US$) in Bosnia and Herzegovina and Imports (BoP, current US$) in Sao Tome and Principe?
Give a very brief answer. 8.67e+09. In the year 2010, what is the difference between the Imports (BoP, current US$) in Bosnia and Herzegovina and Imports (BoP, current US$) in Togo?
Your answer should be compact. 6.97e+09. In the year 2010, what is the difference between the Imports (BoP, current US$) of Sao Tome and Principe and Imports (BoP, current US$) of Togo?
Your answer should be very brief. -1.71e+09. In the year 2011, what is the difference between the Imports (BoP, current US$) of Angola and Imports (BoP, current US$) of Bosnia and Herzegovina?
Keep it short and to the point. 3.35e+1. In the year 2011, what is the difference between the Imports (BoP, current US$) in Angola and Imports (BoP, current US$) in Sao Tome and Principe?
Your answer should be very brief. 4.38e+1. In the year 2011, what is the difference between the Imports (BoP, current US$) in Angola and Imports (BoP, current US$) in Togo?
Your response must be concise. 4.14e+1. In the year 2011, what is the difference between the Imports (BoP, current US$) in Bosnia and Herzegovina and Imports (BoP, current US$) in Sao Tome and Principe?
Provide a short and direct response. 1.03e+1. In the year 2011, what is the difference between the Imports (BoP, current US$) of Bosnia and Herzegovina and Imports (BoP, current US$) of Togo?
Keep it short and to the point. 7.92e+09. In the year 2011, what is the difference between the Imports (BoP, current US$) in Sao Tome and Principe and Imports (BoP, current US$) in Togo?
Ensure brevity in your answer.  -2.35e+09. What is the ratio of the Imports (BoP, current US$) in Angola in 2005 to that in 2006?
Give a very brief answer. 0.93. What is the ratio of the Imports (BoP, current US$) in Bosnia and Herzegovina in 2005 to that in 2006?
Ensure brevity in your answer.  0.97. What is the ratio of the Imports (BoP, current US$) of Sao Tome and Principe in 2005 to that in 2006?
Keep it short and to the point. 0.68. What is the ratio of the Imports (BoP, current US$) in Togo in 2005 to that in 2006?
Your response must be concise. 0.96. What is the ratio of the Imports (BoP, current US$) of Angola in 2005 to that in 2007?
Offer a very short reply. 0.58. What is the ratio of the Imports (BoP, current US$) in Bosnia and Herzegovina in 2005 to that in 2007?
Keep it short and to the point. 0.88. What is the ratio of the Imports (BoP, current US$) of Sao Tome and Principe in 2005 to that in 2007?
Offer a terse response. 0.63. What is the ratio of the Imports (BoP, current US$) in Togo in 2005 to that in 2007?
Offer a very short reply. 0.85. What is the ratio of the Imports (BoP, current US$) in Angola in 2005 to that in 2008?
Make the answer very short. 0.35. What is the ratio of the Imports (BoP, current US$) in Bosnia and Herzegovina in 2005 to that in 2008?
Your answer should be very brief. 0.69. What is the ratio of the Imports (BoP, current US$) of Sao Tome and Principe in 2005 to that in 2008?
Provide a succinct answer. 0.46. What is the ratio of the Imports (BoP, current US$) in Togo in 2005 to that in 2008?
Give a very brief answer. 0.7. What is the ratio of the Imports (BoP, current US$) in Angola in 2005 to that in 2009?
Make the answer very short. 0.36. What is the ratio of the Imports (BoP, current US$) in Bosnia and Herzegovina in 2005 to that in 2009?
Ensure brevity in your answer.  0.91. What is the ratio of the Imports (BoP, current US$) in Sao Tome and Principe in 2005 to that in 2009?
Offer a terse response. 0.51. What is the ratio of the Imports (BoP, current US$) in Togo in 2005 to that in 2009?
Provide a short and direct response. 0.69. What is the ratio of the Imports (BoP, current US$) in Angola in 2005 to that in 2010?
Your answer should be compact. 0.43. What is the ratio of the Imports (BoP, current US$) in Bosnia and Herzegovina in 2005 to that in 2010?
Make the answer very short. 0.9. What is the ratio of the Imports (BoP, current US$) in Sao Tome and Principe in 2005 to that in 2010?
Offer a terse response. 0.44. What is the ratio of the Imports (BoP, current US$) in Togo in 2005 to that in 2010?
Give a very brief answer. 0.64. What is the ratio of the Imports (BoP, current US$) of Angola in 2005 to that in 2011?
Your response must be concise. 0.34. What is the ratio of the Imports (BoP, current US$) in Bosnia and Herzegovina in 2005 to that in 2011?
Offer a very short reply. 0.76. What is the ratio of the Imports (BoP, current US$) in Sao Tome and Principe in 2005 to that in 2011?
Offer a very short reply. 0.36. What is the ratio of the Imports (BoP, current US$) of Togo in 2005 to that in 2011?
Make the answer very short. 0.47. What is the ratio of the Imports (BoP, current US$) in Angola in 2006 to that in 2007?
Make the answer very short. 0.62. What is the ratio of the Imports (BoP, current US$) in Bosnia and Herzegovina in 2006 to that in 2007?
Your answer should be compact. 0.91. What is the ratio of the Imports (BoP, current US$) of Sao Tome and Principe in 2006 to that in 2007?
Your answer should be very brief. 0.92. What is the ratio of the Imports (BoP, current US$) of Togo in 2006 to that in 2007?
Ensure brevity in your answer.  0.88. What is the ratio of the Imports (BoP, current US$) in Angola in 2006 to that in 2008?
Your response must be concise. 0.38. What is the ratio of the Imports (BoP, current US$) of Bosnia and Herzegovina in 2006 to that in 2008?
Your answer should be compact. 0.71. What is the ratio of the Imports (BoP, current US$) of Sao Tome and Principe in 2006 to that in 2008?
Give a very brief answer. 0.68. What is the ratio of the Imports (BoP, current US$) in Togo in 2006 to that in 2008?
Offer a very short reply. 0.73. What is the ratio of the Imports (BoP, current US$) of Angola in 2006 to that in 2009?
Ensure brevity in your answer.  0.39. What is the ratio of the Imports (BoP, current US$) of Bosnia and Herzegovina in 2006 to that in 2009?
Provide a short and direct response. 0.94. What is the ratio of the Imports (BoP, current US$) in Sao Tome and Principe in 2006 to that in 2009?
Your response must be concise. 0.75. What is the ratio of the Imports (BoP, current US$) of Togo in 2006 to that in 2009?
Your answer should be very brief. 0.72. What is the ratio of the Imports (BoP, current US$) in Angola in 2006 to that in 2010?
Your response must be concise. 0.46. What is the ratio of the Imports (BoP, current US$) in Bosnia and Herzegovina in 2006 to that in 2010?
Give a very brief answer. 0.93. What is the ratio of the Imports (BoP, current US$) of Sao Tome and Principe in 2006 to that in 2010?
Offer a terse response. 0.64. What is the ratio of the Imports (BoP, current US$) in Togo in 2006 to that in 2010?
Ensure brevity in your answer.  0.66. What is the ratio of the Imports (BoP, current US$) of Angola in 2006 to that in 2011?
Your answer should be very brief. 0.37. What is the ratio of the Imports (BoP, current US$) in Bosnia and Herzegovina in 2006 to that in 2011?
Offer a terse response. 0.78. What is the ratio of the Imports (BoP, current US$) of Sao Tome and Principe in 2006 to that in 2011?
Give a very brief answer. 0.52. What is the ratio of the Imports (BoP, current US$) of Togo in 2006 to that in 2011?
Offer a terse response. 0.49. What is the ratio of the Imports (BoP, current US$) in Angola in 2007 to that in 2008?
Give a very brief answer. 0.61. What is the ratio of the Imports (BoP, current US$) of Bosnia and Herzegovina in 2007 to that in 2008?
Ensure brevity in your answer.  0.79. What is the ratio of the Imports (BoP, current US$) in Sao Tome and Principe in 2007 to that in 2008?
Your response must be concise. 0.74. What is the ratio of the Imports (BoP, current US$) in Togo in 2007 to that in 2008?
Keep it short and to the point. 0.83. What is the ratio of the Imports (BoP, current US$) in Angola in 2007 to that in 2009?
Provide a succinct answer. 0.63. What is the ratio of the Imports (BoP, current US$) of Bosnia and Herzegovina in 2007 to that in 2009?
Provide a short and direct response. 1.04. What is the ratio of the Imports (BoP, current US$) of Sao Tome and Principe in 2007 to that in 2009?
Keep it short and to the point. 0.81. What is the ratio of the Imports (BoP, current US$) of Togo in 2007 to that in 2009?
Give a very brief answer. 0.82. What is the ratio of the Imports (BoP, current US$) of Angola in 2007 to that in 2010?
Make the answer very short. 0.74. What is the ratio of the Imports (BoP, current US$) of Bosnia and Herzegovina in 2007 to that in 2010?
Give a very brief answer. 1.02. What is the ratio of the Imports (BoP, current US$) in Sao Tome and Principe in 2007 to that in 2010?
Make the answer very short. 0.69. What is the ratio of the Imports (BoP, current US$) in Togo in 2007 to that in 2010?
Your answer should be very brief. 0.75. What is the ratio of the Imports (BoP, current US$) in Angola in 2007 to that in 2011?
Provide a succinct answer. 0.6. What is the ratio of the Imports (BoP, current US$) in Bosnia and Herzegovina in 2007 to that in 2011?
Give a very brief answer. 0.86. What is the ratio of the Imports (BoP, current US$) of Sao Tome and Principe in 2007 to that in 2011?
Make the answer very short. 0.57. What is the ratio of the Imports (BoP, current US$) in Togo in 2007 to that in 2011?
Your answer should be compact. 0.55. What is the ratio of the Imports (BoP, current US$) in Angola in 2008 to that in 2009?
Provide a short and direct response. 1.03. What is the ratio of the Imports (BoP, current US$) in Bosnia and Herzegovina in 2008 to that in 2009?
Keep it short and to the point. 1.32. What is the ratio of the Imports (BoP, current US$) of Sao Tome and Principe in 2008 to that in 2009?
Make the answer very short. 1.11. What is the ratio of the Imports (BoP, current US$) in Togo in 2008 to that in 2009?
Offer a terse response. 0.99. What is the ratio of the Imports (BoP, current US$) of Angola in 2008 to that in 2010?
Ensure brevity in your answer.  1.22. What is the ratio of the Imports (BoP, current US$) in Bosnia and Herzegovina in 2008 to that in 2010?
Your response must be concise. 1.3. What is the ratio of the Imports (BoP, current US$) in Sao Tome and Principe in 2008 to that in 2010?
Your answer should be compact. 0.94. What is the ratio of the Imports (BoP, current US$) in Togo in 2008 to that in 2010?
Make the answer very short. 0.91. What is the ratio of the Imports (BoP, current US$) of Angola in 2008 to that in 2011?
Your response must be concise. 0.98. What is the ratio of the Imports (BoP, current US$) of Bosnia and Herzegovina in 2008 to that in 2011?
Provide a short and direct response. 1.09. What is the ratio of the Imports (BoP, current US$) of Sao Tome and Principe in 2008 to that in 2011?
Your answer should be compact. 0.77. What is the ratio of the Imports (BoP, current US$) in Togo in 2008 to that in 2011?
Your response must be concise. 0.67. What is the ratio of the Imports (BoP, current US$) of Angola in 2009 to that in 2010?
Ensure brevity in your answer.  1.18. What is the ratio of the Imports (BoP, current US$) in Bosnia and Herzegovina in 2009 to that in 2010?
Keep it short and to the point. 0.98. What is the ratio of the Imports (BoP, current US$) of Sao Tome and Principe in 2009 to that in 2010?
Offer a very short reply. 0.85. What is the ratio of the Imports (BoP, current US$) of Togo in 2009 to that in 2010?
Make the answer very short. 0.92. What is the ratio of the Imports (BoP, current US$) of Angola in 2009 to that in 2011?
Give a very brief answer. 0.95. What is the ratio of the Imports (BoP, current US$) of Bosnia and Herzegovina in 2009 to that in 2011?
Keep it short and to the point. 0.83. What is the ratio of the Imports (BoP, current US$) of Sao Tome and Principe in 2009 to that in 2011?
Your answer should be compact. 0.7. What is the ratio of the Imports (BoP, current US$) of Togo in 2009 to that in 2011?
Your answer should be compact. 0.68. What is the ratio of the Imports (BoP, current US$) of Angola in 2010 to that in 2011?
Offer a very short reply. 0.81. What is the ratio of the Imports (BoP, current US$) in Bosnia and Herzegovina in 2010 to that in 2011?
Your answer should be compact. 0.84. What is the ratio of the Imports (BoP, current US$) of Sao Tome and Principe in 2010 to that in 2011?
Give a very brief answer. 0.82. What is the ratio of the Imports (BoP, current US$) in Togo in 2010 to that in 2011?
Provide a succinct answer. 0.73. What is the difference between the highest and the second highest Imports (BoP, current US$) of Angola?
Ensure brevity in your answer.  7.77e+08. What is the difference between the highest and the second highest Imports (BoP, current US$) of Bosnia and Herzegovina?
Provide a short and direct response. 9.82e+08. What is the difference between the highest and the second highest Imports (BoP, current US$) in Sao Tome and Principe?
Your answer should be compact. 2.66e+07. What is the difference between the highest and the second highest Imports (BoP, current US$) of Togo?
Your response must be concise. 6.65e+08. What is the difference between the highest and the lowest Imports (BoP, current US$) of Angola?
Your answer should be compact. 2.88e+1. What is the difference between the highest and the lowest Imports (BoP, current US$) of Bosnia and Herzegovina?
Offer a terse response. 3.51e+09. What is the difference between the highest and the lowest Imports (BoP, current US$) of Sao Tome and Principe?
Provide a succinct answer. 9.44e+07. What is the difference between the highest and the lowest Imports (BoP, current US$) of Togo?
Your answer should be compact. 1.33e+09. 